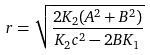<formula> <loc_0><loc_0><loc_500><loc_500>r = \sqrt { \frac { 2 K _ { 2 } ( A ^ { 2 } + B ^ { 2 } ) } { K _ { 2 } c ^ { 2 } - 2 B K _ { 1 } } }</formula> 